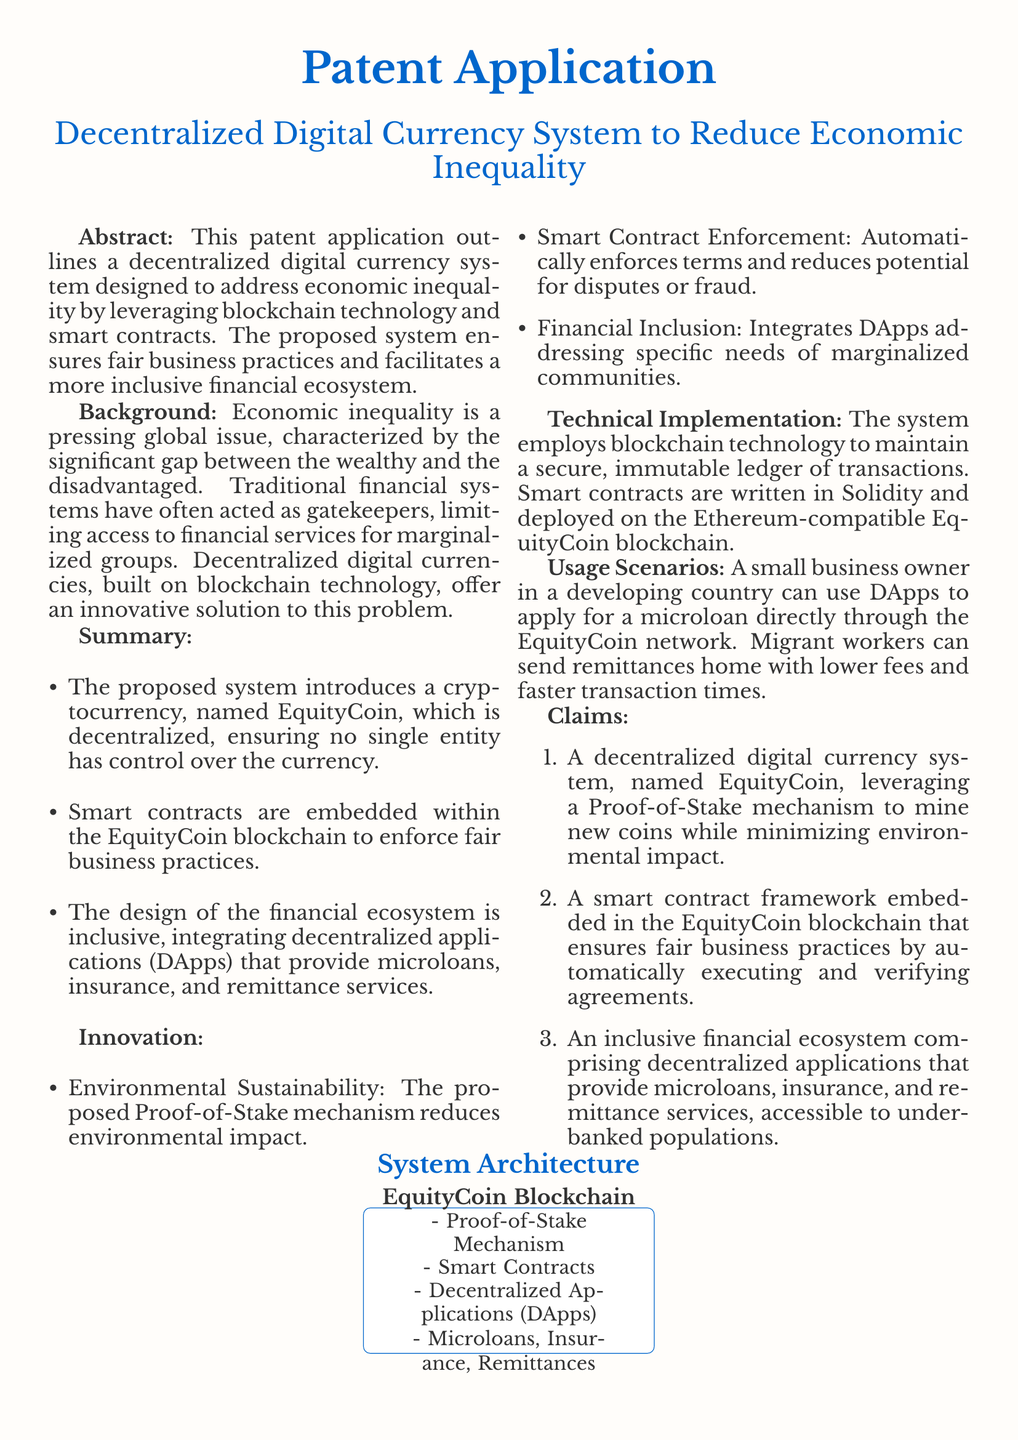What is the name of the proposed cryptocurrency? The document states that the proposed cryptocurrency is named EquityCoin.
Answer: EquityCoin What mechanism does EquityCoin use for mining? The document mentions that EquityCoin leverages a Proof-of-Stake mechanism to mine new coins.
Answer: Proof-of-Stake What technology is used to maintain a secure ledger of transactions? The document indicates that blockchain technology is employed to maintain a secure, immutable ledger.
Answer: Blockchain technology What is a key feature of the smart contracts in EquityCoin? The smart contracts automatically execute and verify agreements, ensuring fair business practices.
Answer: Automatic execution What services do the decentralized applications provide? The document lists that the decentralized applications provide microloans, insurance, and remittance services.
Answer: Microloans, insurance, remittances How does the proposed system aim to reduce environmental impact? The system's Proof-of-Stake mechanism is designed to minimize environmental impact.
Answer: Minimizing environmental impact What issue does the decentralized digital currency system primarily address? The document outlines that the system aims to address economic inequality.
Answer: Economic inequality Which programming language is used for writing smart contracts? The document states that smart contracts are written in Solidity.
Answer: Solidity What is the overall goal of the financial ecosystem designed with EquityCoin? The document describes the ecosystem's goal as being inclusive for underbanked populations.
Answer: Inclusive financial ecosystem 